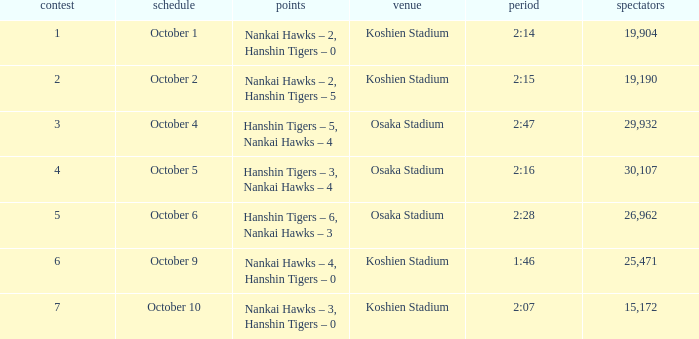How many games have an Attendance of 19,190? 1.0. 